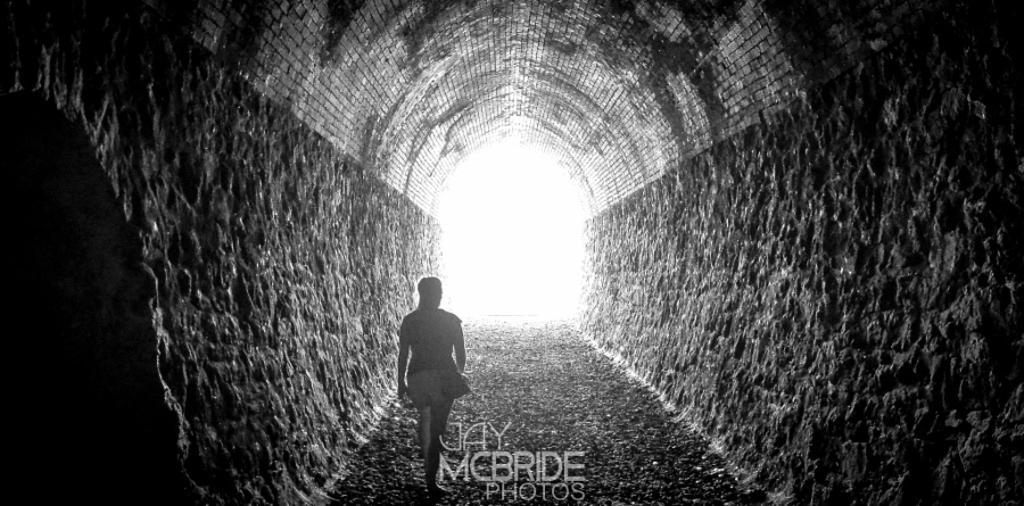Can you describe this image briefly? In this image I can see a woman is walking. At the bottom there is the waterfall. 